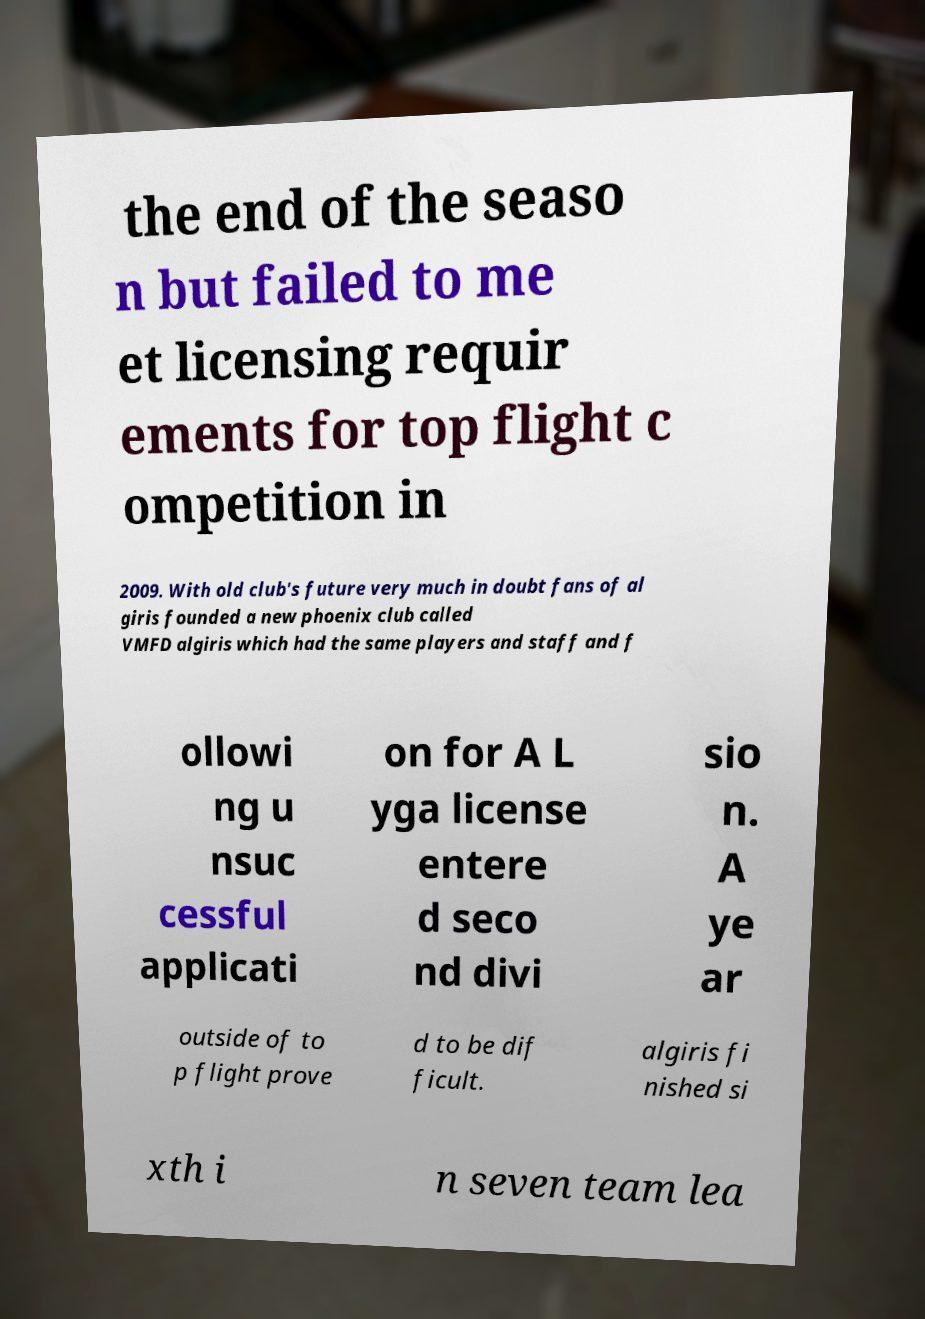Can you read and provide the text displayed in the image?This photo seems to have some interesting text. Can you extract and type it out for me? the end of the seaso n but failed to me et licensing requir ements for top flight c ompetition in 2009. With old club's future very much in doubt fans of al giris founded a new phoenix club called VMFD algiris which had the same players and staff and f ollowi ng u nsuc cessful applicati on for A L yga license entere d seco nd divi sio n. A ye ar outside of to p flight prove d to be dif ficult. algiris fi nished si xth i n seven team lea 